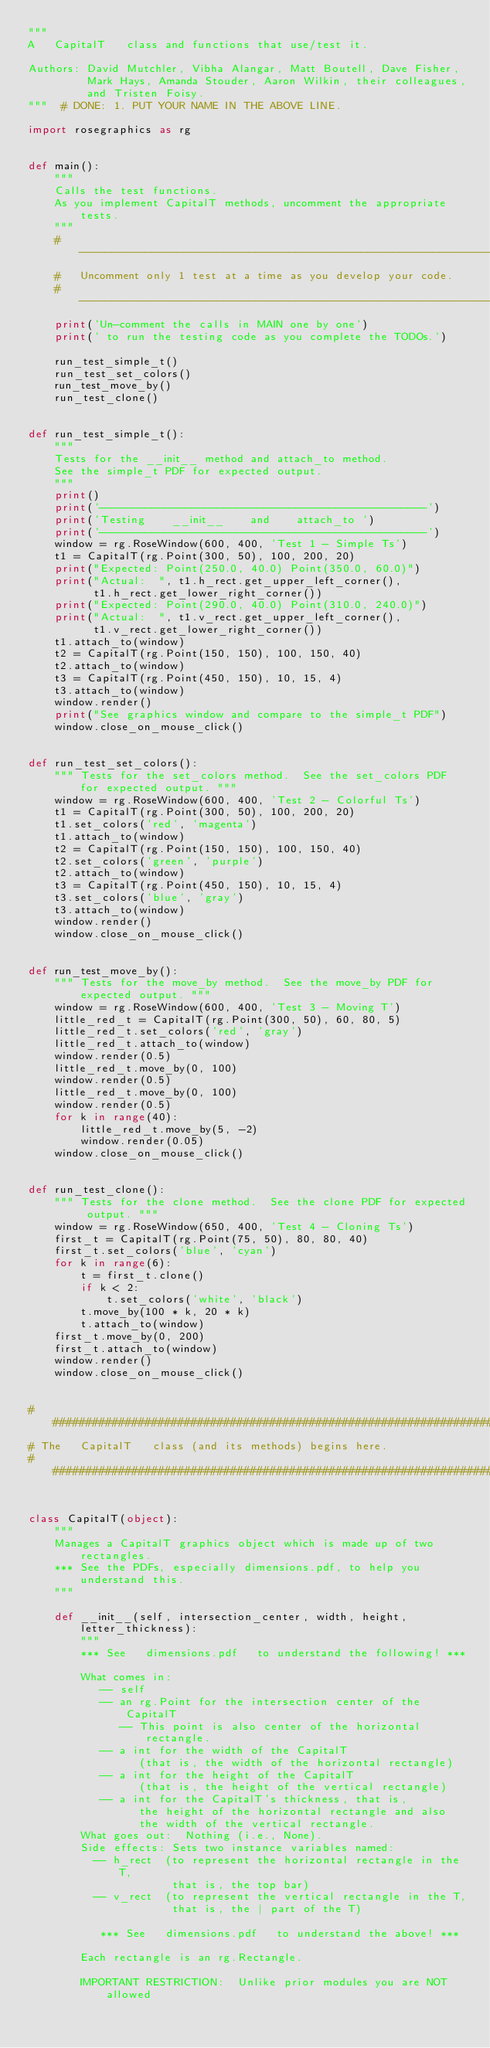<code> <loc_0><loc_0><loc_500><loc_500><_Python_>"""
A   CapitalT   class and functions that use/test it.

Authors: David Mutchler, Vibha Alangar, Matt Boutell, Dave Fisher,
         Mark Hays, Amanda Stouder, Aaron Wilkin, their colleagues,
         and Tristen Foisy.
"""  # DONE: 1. PUT YOUR NAME IN THE ABOVE LINE.

import rosegraphics as rg


def main():
    """
    Calls the test functions.
    As you implement CapitalT methods, uncomment the appropriate tests.
    """
    # -------------------------------------------------------------------------
    #   Uncomment only 1 test at a time as you develop your code.
    # -------------------------------------------------------------------------
    print('Un-comment the calls in MAIN one by one')
    print(' to run the testing code as you complete the TODOs.')

    run_test_simple_t()
    run_test_set_colors()
    run_test_move_by()
    run_test_clone()


def run_test_simple_t():
    """
    Tests for the __init__ method and attach_to method.
    See the simple_t PDF for expected output.
    """
    print()
    print('--------------------------------------------------')
    print('Testing    __init__    and    attach_to ')
    print('--------------------------------------------------')
    window = rg.RoseWindow(600, 400, 'Test 1 - Simple Ts')
    t1 = CapitalT(rg.Point(300, 50), 100, 200, 20)
    print("Expected: Point(250.0, 40.0) Point(350.0, 60.0)")
    print("Actual:  ", t1.h_rect.get_upper_left_corner(),
          t1.h_rect.get_lower_right_corner())
    print("Expected: Point(290.0, 40.0) Point(310.0, 240.0)")
    print("Actual:  ", t1.v_rect.get_upper_left_corner(),
          t1.v_rect.get_lower_right_corner())
    t1.attach_to(window)
    t2 = CapitalT(rg.Point(150, 150), 100, 150, 40)
    t2.attach_to(window)
    t3 = CapitalT(rg.Point(450, 150), 10, 15, 4)
    t3.attach_to(window)
    window.render()
    print("See graphics window and compare to the simple_t PDF")
    window.close_on_mouse_click()


def run_test_set_colors():
    """ Tests for the set_colors method.  See the set_colors PDF for expected output. """
    window = rg.RoseWindow(600, 400, 'Test 2 - Colorful Ts')
    t1 = CapitalT(rg.Point(300, 50), 100, 200, 20)
    t1.set_colors('red', 'magenta')
    t1.attach_to(window)
    t2 = CapitalT(rg.Point(150, 150), 100, 150, 40)
    t2.set_colors('green', 'purple')
    t2.attach_to(window)
    t3 = CapitalT(rg.Point(450, 150), 10, 15, 4)
    t3.set_colors('blue', 'gray')
    t3.attach_to(window)
    window.render()
    window.close_on_mouse_click()


def run_test_move_by():
    """ Tests for the move_by method.  See the move_by PDF for expected output. """
    window = rg.RoseWindow(600, 400, 'Test 3 - Moving T')
    little_red_t = CapitalT(rg.Point(300, 50), 60, 80, 5)
    little_red_t.set_colors('red', 'gray')
    little_red_t.attach_to(window)
    window.render(0.5)
    little_red_t.move_by(0, 100)
    window.render(0.5)
    little_red_t.move_by(0, 100)
    window.render(0.5)
    for k in range(40):
        little_red_t.move_by(5, -2)
        window.render(0.05)
    window.close_on_mouse_click()


def run_test_clone():
    """ Tests for the clone method.  See the clone PDF for expected output. """
    window = rg.RoseWindow(650, 400, 'Test 4 - Cloning Ts')
    first_t = CapitalT(rg.Point(75, 50), 80, 80, 40)
    first_t.set_colors('blue', 'cyan')
    for k in range(6):
        t = first_t.clone()
        if k < 2:
            t.set_colors('white', 'black')
        t.move_by(100 * k, 20 * k)
        t.attach_to(window)
    first_t.move_by(0, 200)
    first_t.attach_to(window)
    window.render()
    window.close_on_mouse_click()


###############################################################################
# The   CapitalT   class (and its methods) begins here.
###############################################################################


class CapitalT(object):
    """
    Manages a CapitalT graphics object which is made up of two rectangles.
    *** See the PDFs, especially dimensions.pdf, to help you understand this.
    """

    def __init__(self, intersection_center, width, height, letter_thickness):
        """
        *** See   dimensions.pdf   to understand the following! ***

        What comes in:
           -- self
           -- an rg.Point for the intersection center of the CapitalT
              -- This point is also center of the horizontal rectangle.
           -- a int for the width of the CapitalT
                 (that is, the width of the horizontal rectangle)
           -- a int for the height of the CapitalT
                 (that is, the height of the vertical rectangle)
           -- a int for the CapitalT's thickness, that is,
                 the height of the horizontal rectangle and also
                 the width of the vertical rectangle.
        What goes out:  Nothing (i.e., None).
        Side effects: Sets two instance variables named:
          -- h_rect  (to represent the horizontal rectangle in the T,
                      that is, the top bar)
          -- v_rect  (to represent the vertical rectangle in the T,
                      that is, the | part of the T)

           *** See   dimensions.pdf   to understand the above! ***

        Each rectangle is an rg.Rectangle.

        IMPORTANT RESTRICTION:  Unlike prior modules you are NOT allowed</code> 